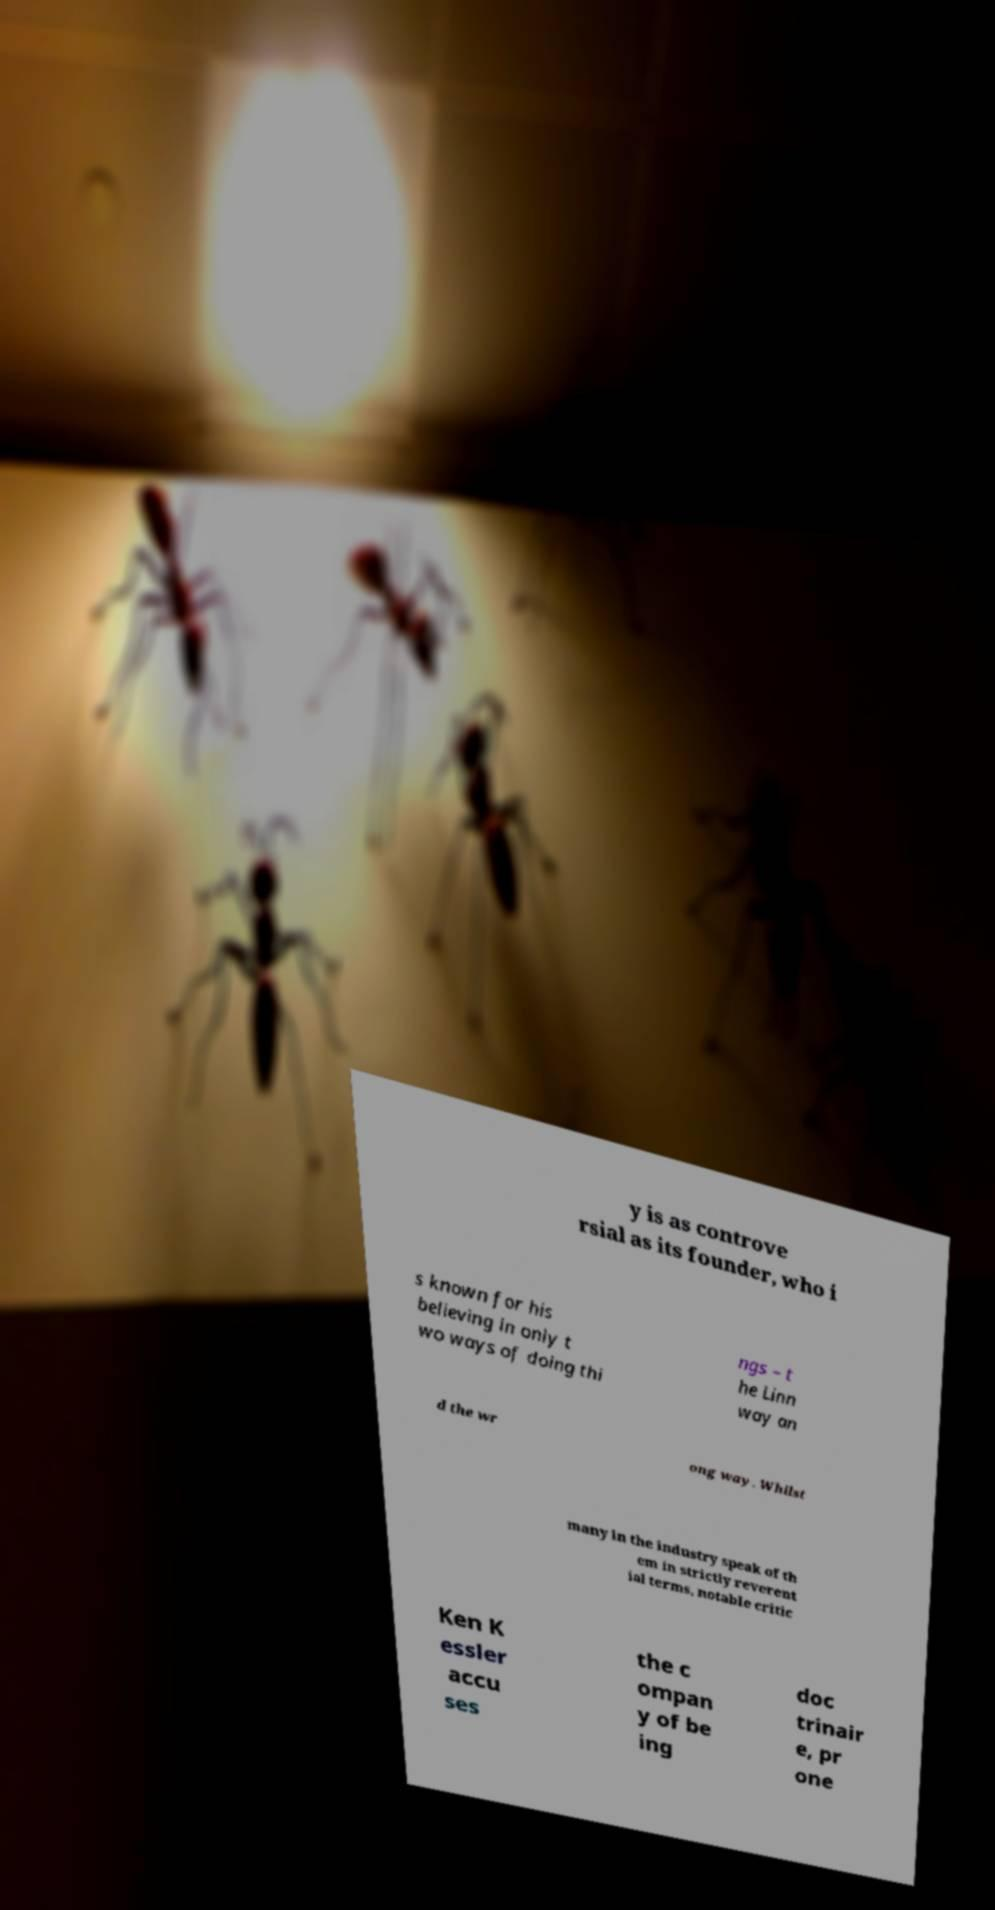I need the written content from this picture converted into text. Can you do that? y is as controve rsial as its founder, who i s known for his believing in only t wo ways of doing thi ngs – t he Linn way an d the wr ong way. Whilst many in the industry speak of th em in strictly reverent ial terms, notable critic Ken K essler accu ses the c ompan y of be ing doc trinair e, pr one 